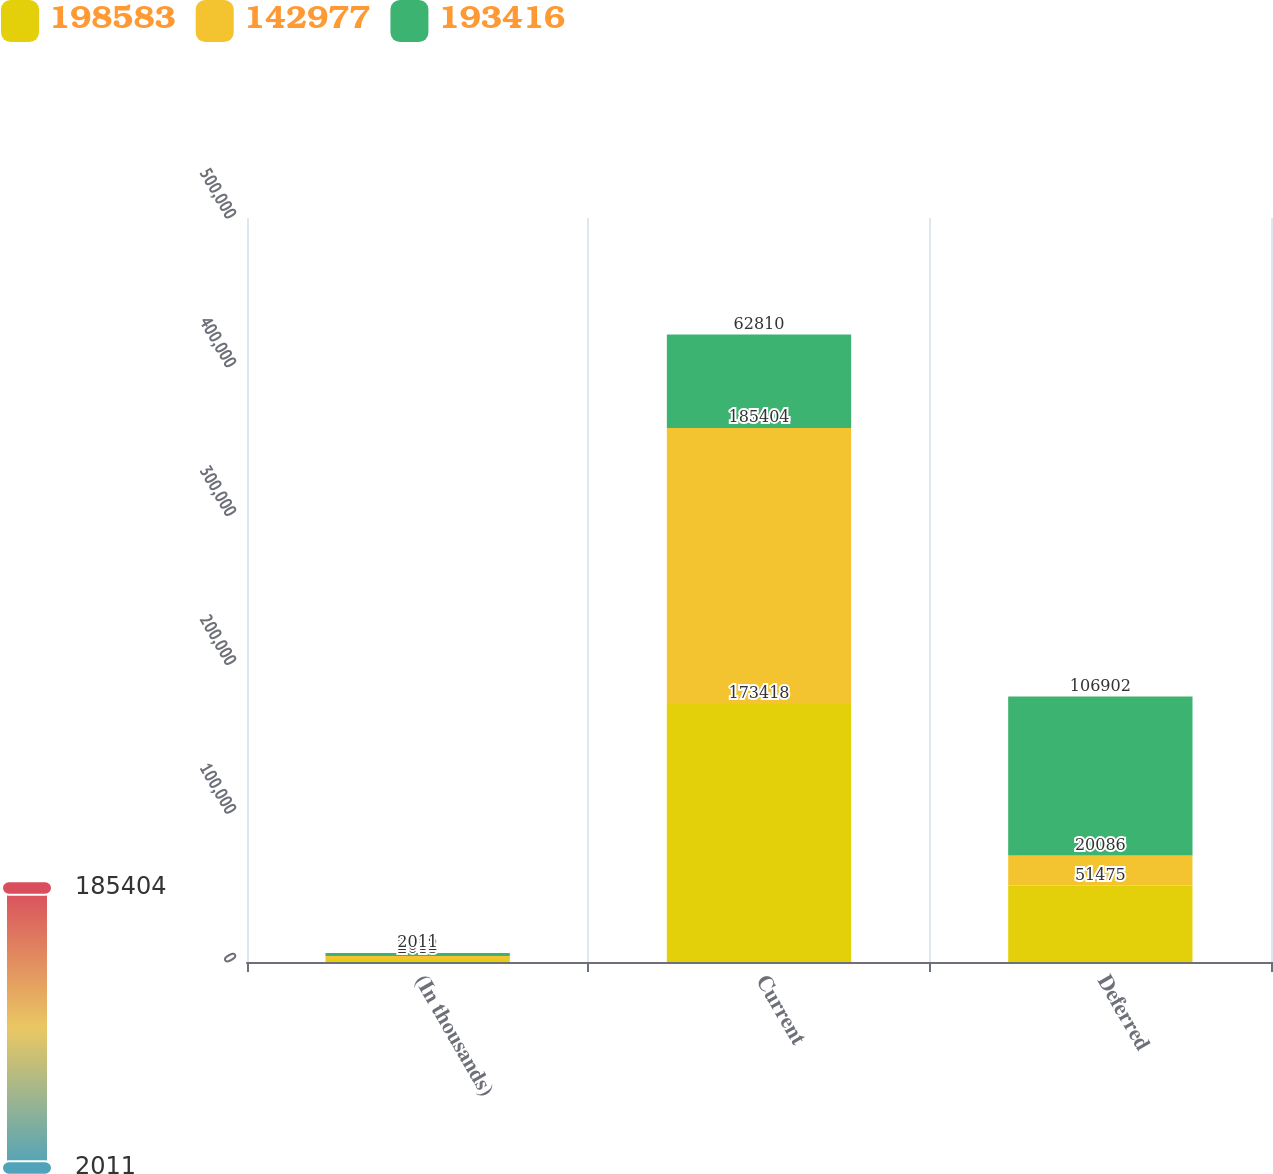<chart> <loc_0><loc_0><loc_500><loc_500><stacked_bar_chart><ecel><fcel>(In thousands)<fcel>Current<fcel>Deferred<nl><fcel>198583<fcel>2013<fcel>173418<fcel>51475<nl><fcel>142977<fcel>2012<fcel>185404<fcel>20086<nl><fcel>193416<fcel>2011<fcel>62810<fcel>106902<nl></chart> 